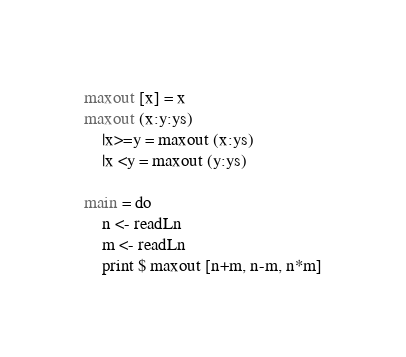Convert code to text. <code><loc_0><loc_0><loc_500><loc_500><_Haskell_>maxout [x] = x
maxout (x:y:ys)
    |x>=y = maxout (x:ys)
    |x <y = maxout (y:ys)
    
main = do
    n <- readLn
    m <- readLn
    print $ maxout [n+m, n-m, n*m]</code> 